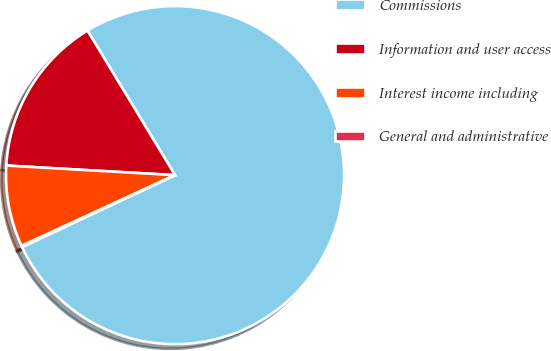Convert chart. <chart><loc_0><loc_0><loc_500><loc_500><pie_chart><fcel>Commissions<fcel>Information and user access<fcel>Interest income including<fcel>General and administrative<nl><fcel>76.67%<fcel>15.43%<fcel>7.78%<fcel>0.12%<nl></chart> 